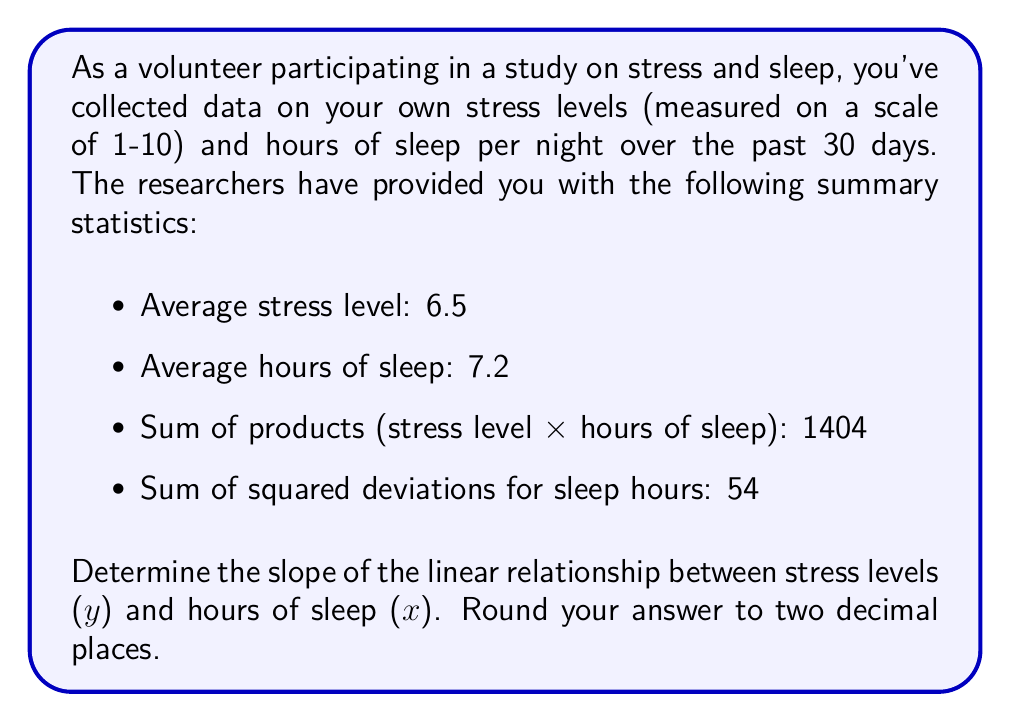What is the answer to this math problem? To find the slope of the linear relationship, we'll use the formula for the slope in a linear regression model:

$$ m = \frac{n\sum xy - \sum x \sum y}{n\sum x^2 - (\sum x)^2} $$

Where:
- $m$ is the slope
- $n$ is the number of data points (30 in this case)
- $\sum xy$ is the sum of products (1404)
- $\sum x$ is the sum of x values (hours of sleep)
- $\sum y$ is the sum of y values (stress levels)
- $\sum x^2$ is the sum of squared x values

Let's calculate the missing values:

1. $\sum x = n \times \text{average hours of sleep} = 30 \times 7.2 = 216$
2. $\sum y = n \times \text{average stress level} = 30 \times 6.5 = 195$

Now, we need to calculate $\sum x^2$. We can use the formula for the sum of squared deviations:

$$ \sum (x - \bar{x})^2 = \sum x^2 - \frac{(\sum x)^2}{n} $$

Rearranging this, we get:

$$ \sum x^2 = \sum (x - \bar{x})^2 + \frac{(\sum x)^2}{n} $$

Plugging in the values:

$$ \sum x^2 = 54 + \frac{216^2}{30} = 54 + 1555.2 = 1609.2 $$

Now we have all the values to calculate the slope:

$$ m = \frac{30 \times 1404 - 216 \times 195}{30 \times 1609.2 - 216^2} $$

$$ m = \frac{42120 - 42120}{48276 - 46656} $$

$$ m = \frac{0}{1620} = 0 $$

The slope is 0, which means there is no linear relationship between stress levels and hours of sleep in this dataset.
Answer: $m = 0.00$ 